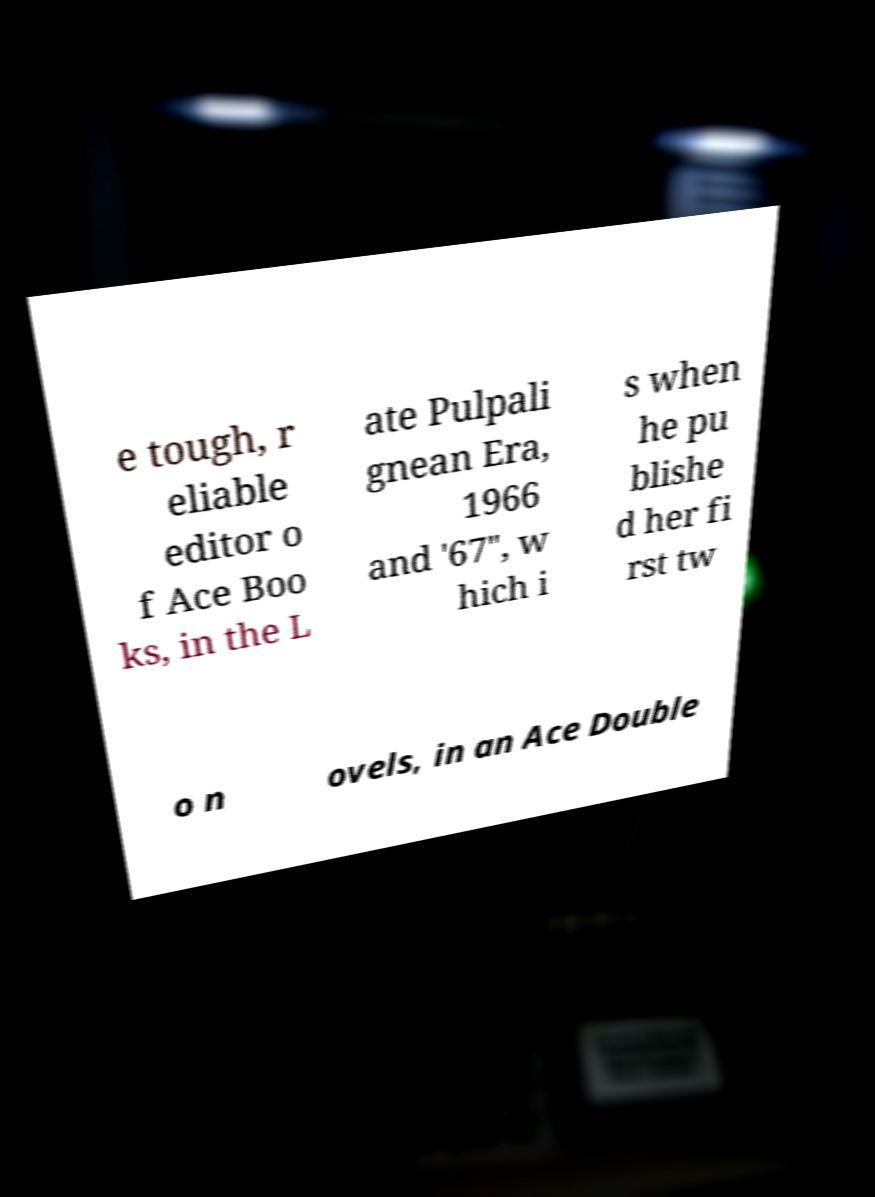There's text embedded in this image that I need extracted. Can you transcribe it verbatim? e tough, r eliable editor o f Ace Boo ks, in the L ate Pulpali gnean Era, 1966 and '67", w hich i s when he pu blishe d her fi rst tw o n ovels, in an Ace Double 